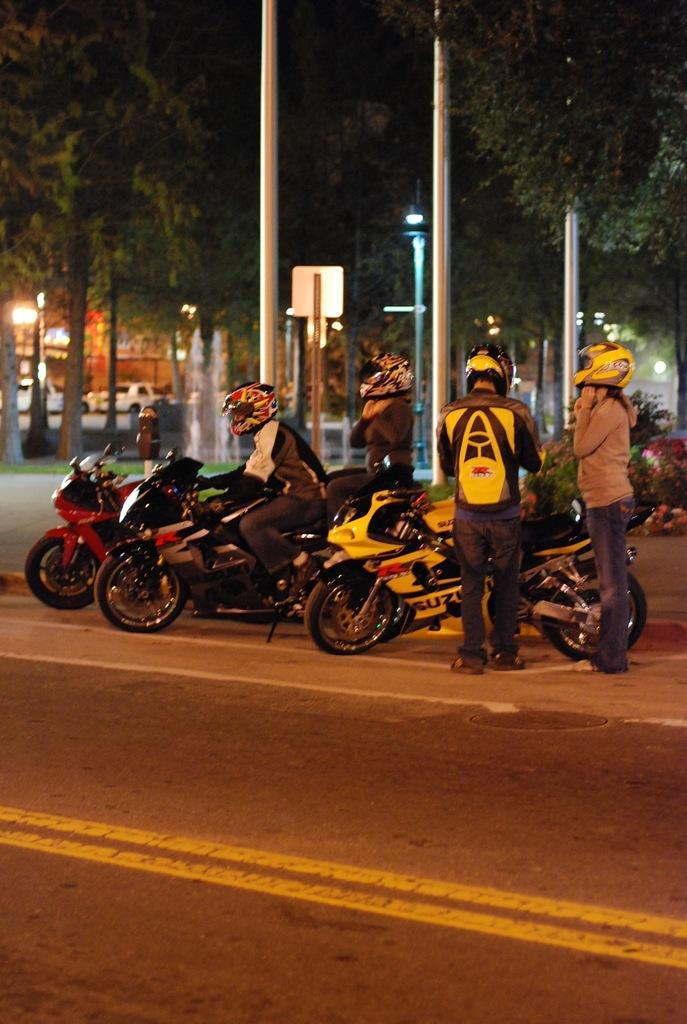How many bikes are in the image? There are three bikes in the image. How many people are in the image? There are four people in the image. What safety gear are the people wearing? The people are wearing helmets. What else are the people carrying in the image? The people are wearing backpacks. What type of natural elements can be seen in the image? There are trees in the image. What man-made structures are present in the image? There are poles in the image. What type of engine can be seen powering the bikes in the image? There are no engines visible in the image, as the bikes are likely regular bicycles. Can you spot a squirrel climbing one of the trees in the image? There is no squirrel present in the image; only the people, bikes, trees, and poles are visible. 